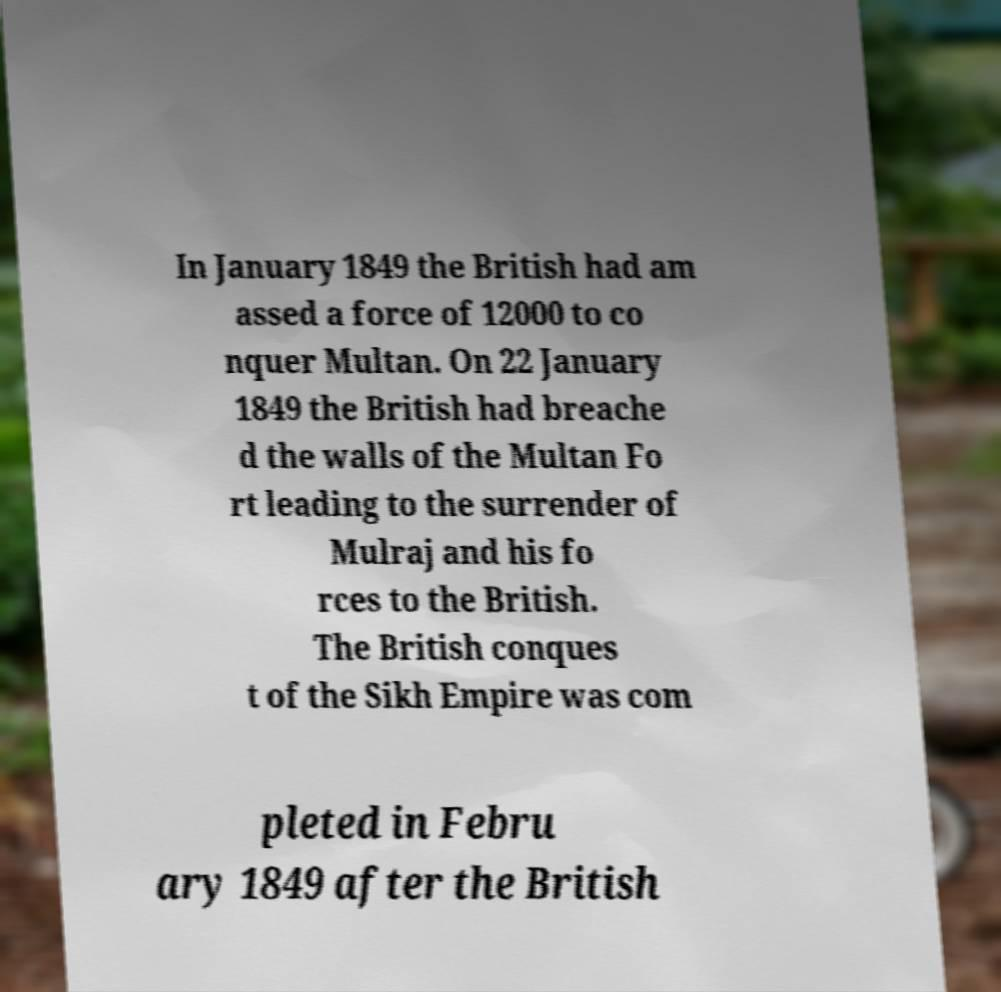Can you read and provide the text displayed in the image?This photo seems to have some interesting text. Can you extract and type it out for me? In January 1849 the British had am assed a force of 12000 to co nquer Multan. On 22 January 1849 the British had breache d the walls of the Multan Fo rt leading to the surrender of Mulraj and his fo rces to the British. The British conques t of the Sikh Empire was com pleted in Febru ary 1849 after the British 